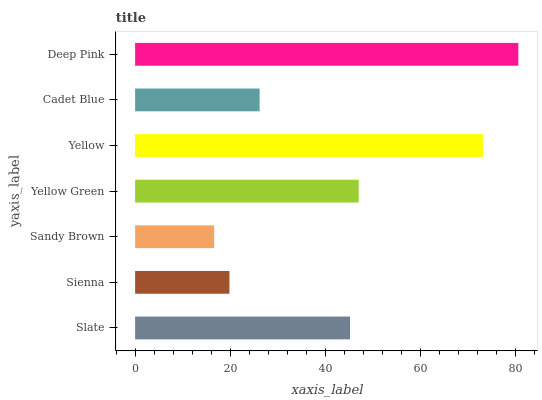Is Sandy Brown the minimum?
Answer yes or no. Yes. Is Deep Pink the maximum?
Answer yes or no. Yes. Is Sienna the minimum?
Answer yes or no. No. Is Sienna the maximum?
Answer yes or no. No. Is Slate greater than Sienna?
Answer yes or no. Yes. Is Sienna less than Slate?
Answer yes or no. Yes. Is Sienna greater than Slate?
Answer yes or no. No. Is Slate less than Sienna?
Answer yes or no. No. Is Slate the high median?
Answer yes or no. Yes. Is Slate the low median?
Answer yes or no. Yes. Is Sandy Brown the high median?
Answer yes or no. No. Is Deep Pink the low median?
Answer yes or no. No. 